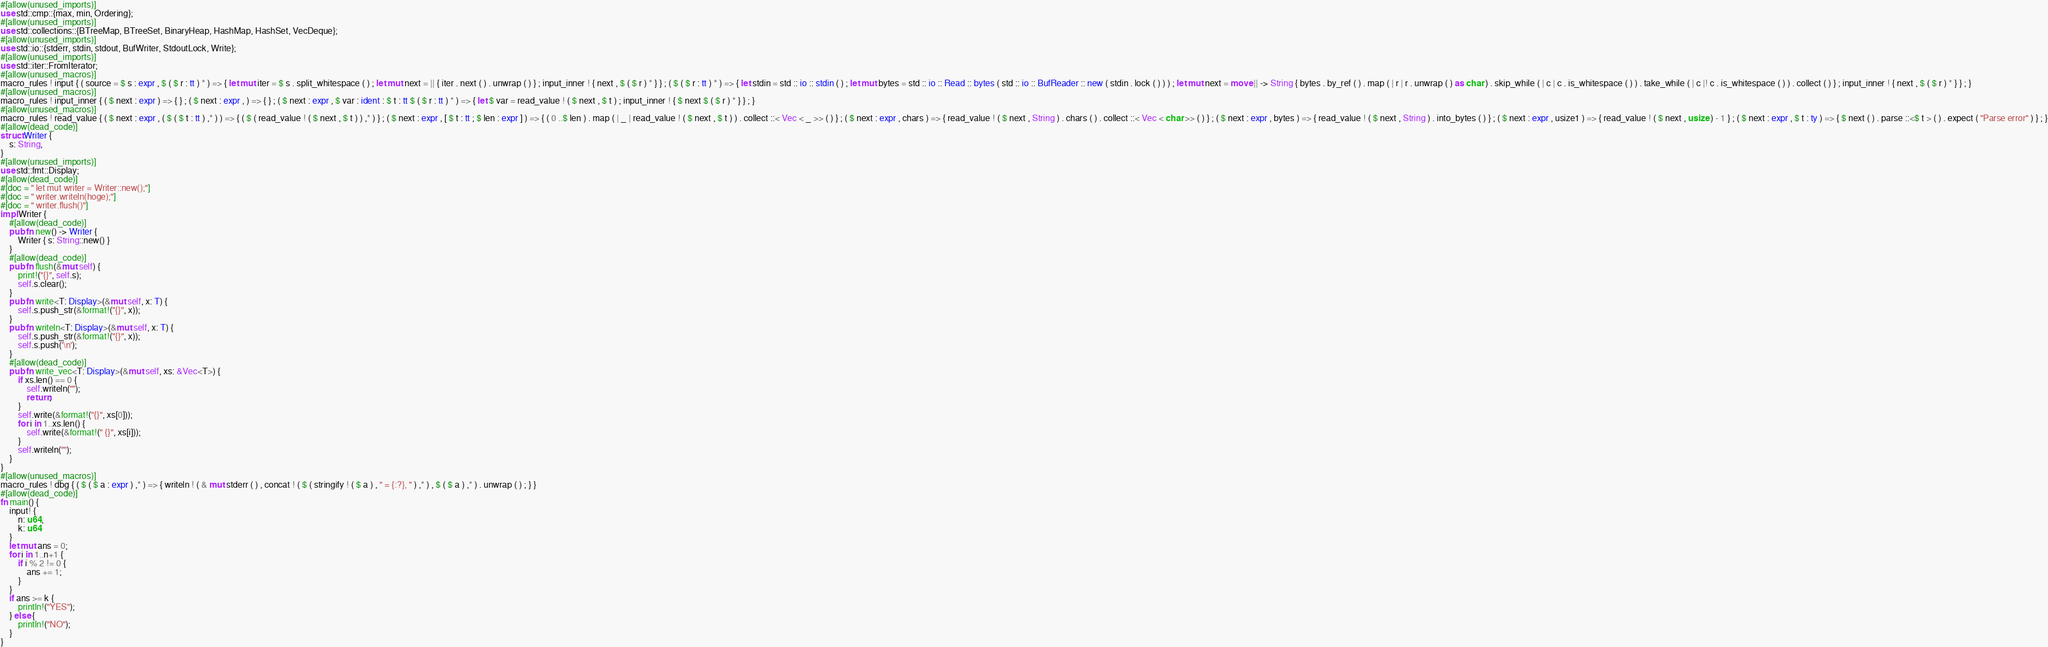<code> <loc_0><loc_0><loc_500><loc_500><_Rust_>#[allow(unused_imports)]
use std::cmp::{max, min, Ordering};
#[allow(unused_imports)]
use std::collections::{BTreeMap, BTreeSet, BinaryHeap, HashMap, HashSet, VecDeque};
#[allow(unused_imports)]
use std::io::{stderr, stdin, stdout, BufWriter, StdoutLock, Write};
#[allow(unused_imports)]
use std::iter::FromIterator;
#[allow(unused_macros)]
macro_rules ! input { ( source = $ s : expr , $ ( $ r : tt ) * ) => { let mut iter = $ s . split_whitespace ( ) ; let mut next = || { iter . next ( ) . unwrap ( ) } ; input_inner ! { next , $ ( $ r ) * } } ; ( $ ( $ r : tt ) * ) => { let stdin = std :: io :: stdin ( ) ; let mut bytes = std :: io :: Read :: bytes ( std :: io :: BufReader :: new ( stdin . lock ( ) ) ) ; let mut next = move || -> String { bytes . by_ref ( ) . map ( | r | r . unwrap ( ) as char ) . skip_while ( | c | c . is_whitespace ( ) ) . take_while ( | c |! c . is_whitespace ( ) ) . collect ( ) } ; input_inner ! { next , $ ( $ r ) * } } ; }
#[allow(unused_macros)]
macro_rules ! input_inner { ( $ next : expr ) => { } ; ( $ next : expr , ) => { } ; ( $ next : expr , $ var : ident : $ t : tt $ ( $ r : tt ) * ) => { let $ var = read_value ! ( $ next , $ t ) ; input_inner ! { $ next $ ( $ r ) * } } ; }
#[allow(unused_macros)]
macro_rules ! read_value { ( $ next : expr , ( $ ( $ t : tt ) ,* ) ) => { ( $ ( read_value ! ( $ next , $ t ) ) ,* ) } ; ( $ next : expr , [ $ t : tt ; $ len : expr ] ) => { ( 0 ..$ len ) . map ( | _ | read_value ! ( $ next , $ t ) ) . collect ::< Vec < _ >> ( ) } ; ( $ next : expr , chars ) => { read_value ! ( $ next , String ) . chars ( ) . collect ::< Vec < char >> ( ) } ; ( $ next : expr , bytes ) => { read_value ! ( $ next , String ) . into_bytes ( ) } ; ( $ next : expr , usize1 ) => { read_value ! ( $ next , usize ) - 1 } ; ( $ next : expr , $ t : ty ) => { $ next ( ) . parse ::<$ t > ( ) . expect ( "Parse error" ) } ; }
#[allow(dead_code)]
struct Writer {
    s: String,
}
#[allow(unused_imports)]
use std::fmt::Display;
#[allow(dead_code)]
#[doc = " let mut writer = Writer::new();"]
#[doc = " writer.writeln(hoge);"]
#[doc = " writer.flush()"]
impl Writer {
    #[allow(dead_code)]
    pub fn new() -> Writer {
        Writer { s: String::new() }
    }
    #[allow(dead_code)]
    pub fn flush(&mut self) {
        print!("{}", self.s);
        self.s.clear();
    }
    pub fn write<T: Display>(&mut self, x: T) {
        self.s.push_str(&format!("{}", x));
    }
    pub fn writeln<T: Display>(&mut self, x: T) {
        self.s.push_str(&format!("{}", x));
        self.s.push('\n');
    }
    #[allow(dead_code)]
    pub fn write_vec<T: Display>(&mut self, xs: &Vec<T>) {
        if xs.len() == 0 {
            self.writeln("");
            return;
        }
        self.write(&format!("{}", xs[0]));
        for i in 1..xs.len() {
            self.write(&format!(" {}", xs[i]));
        }
        self.writeln("");
    }
}
#[allow(unused_macros)]
macro_rules ! dbg { ( $ ( $ a : expr ) ,* ) => { writeln ! ( & mut stderr ( ) , concat ! ( $ ( stringify ! ( $ a ) , " = {:?}, " ) ,* ) , $ ( $ a ) ,* ) . unwrap ( ) ; } }
#[allow(dead_code)]
fn main() {
    input! {
        n: u64,
        k: u64
    }
    let mut ans = 0;
    for i in 1..n+1 {
        if i % 2 != 0 {
            ans += 1;
        }
    }
    if ans >= k {
        println!("YES");
    } else {
        println!("NO");
    }
}</code> 